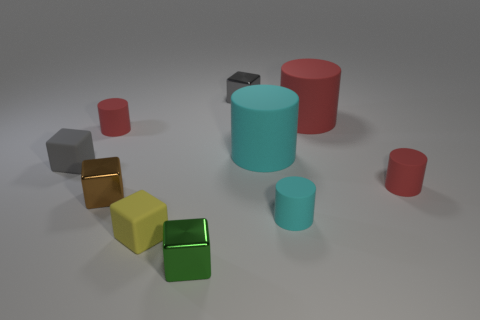The rubber cube that is the same size as the yellow object is what color?
Your answer should be very brief. Gray. Is there a tiny gray metallic thing that has the same shape as the small green thing?
Your answer should be compact. Yes. The yellow matte thing is what shape?
Ensure brevity in your answer.  Cube. Are there more small metallic cubes in front of the large cyan matte cylinder than tiny red cylinders that are in front of the tiny green block?
Offer a very short reply. Yes. How many other things are the same size as the brown cube?
Ensure brevity in your answer.  7. The cube that is both behind the brown shiny object and right of the brown object is made of what material?
Keep it short and to the point. Metal. There is a brown object that is the same shape as the tiny green thing; what material is it?
Give a very brief answer. Metal. There is a small gray thing right of the gray matte thing behind the tiny cyan matte cylinder; what number of cylinders are on the right side of it?
Your response must be concise. 4. How many cylinders are in front of the big red matte object and right of the gray shiny block?
Offer a terse response. 3. Is the size of the matte cylinder that is left of the yellow matte cube the same as the yellow rubber object to the left of the green cube?
Offer a terse response. Yes. 